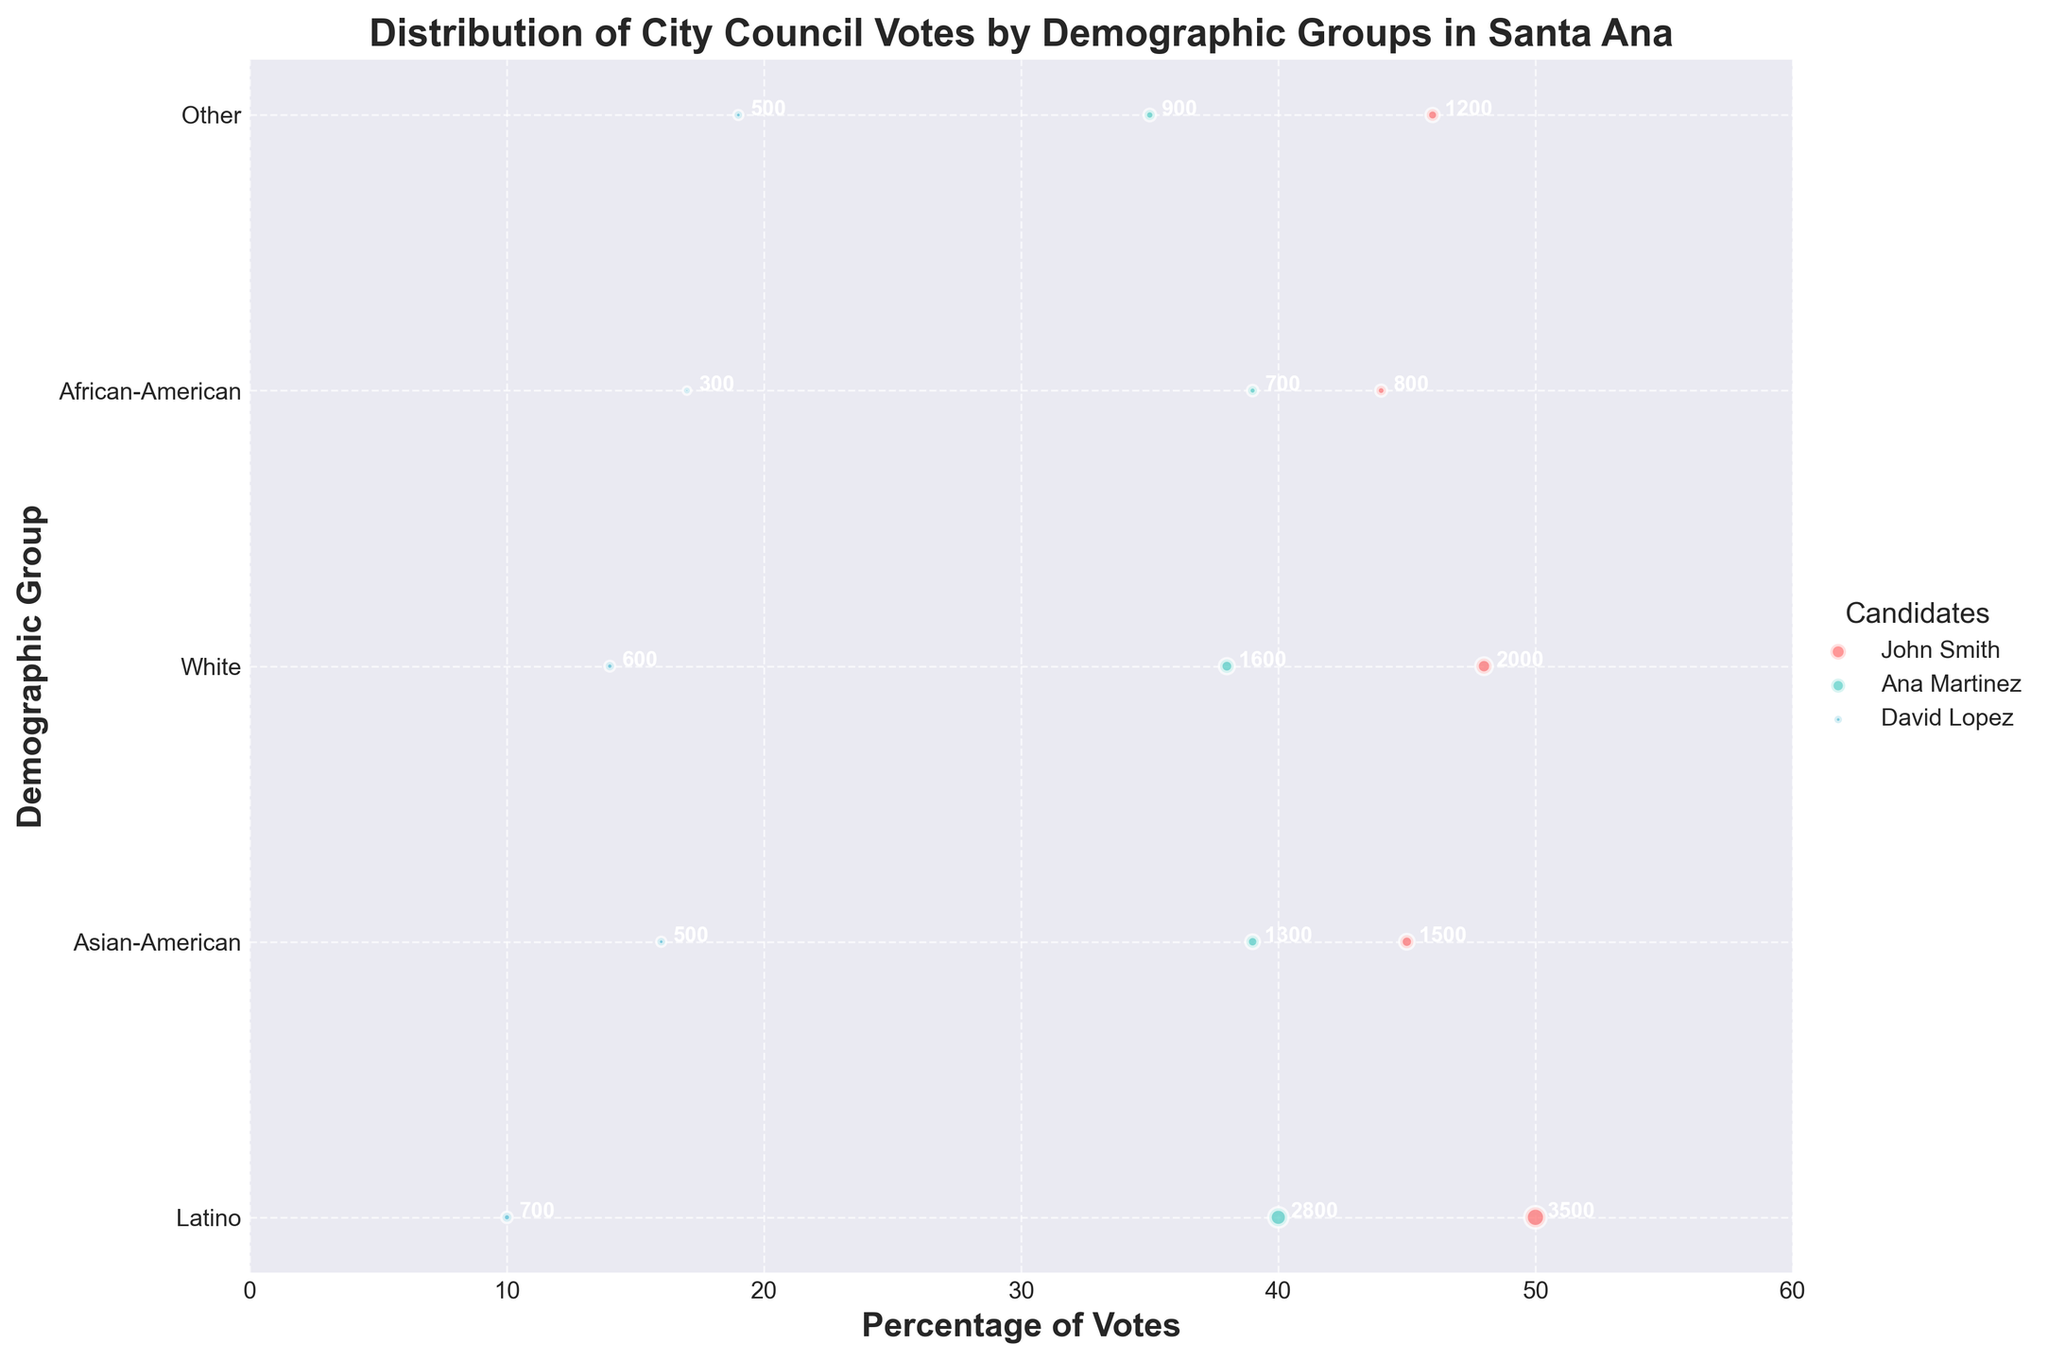What is the title of the figure? The title is usually mentioned at the top of the figure and is labeled "Distribution of City Council Votes by Demographic Groups in Santa Ana."
Answer: Distribution of City Council Votes by Demographic Groups in Santa Ana Which candidate received the most votes overall among all demographic groups? John Smith appears to have larger-sized bubbles across most demographic groups. The sizes are proportional to the number of votes, indicating he received the most votes overall.
Answer: John Smith Which demographic group gave the highest percentage of votes to Ana Martinez? By referring to the x-axis (Percentage of Votes) and comparing the positions of the bubbles for Ana Martinez, the Asian-American group gave her the highest percentage of votes at 39%.
Answer: Asian-American How many votes did David Lopez receive from the Latino demographic group? Each bubble is annotated with the number of votes. The bubble for David Lopez in the Latino group shows 700 votes.
Answer: 700 Which demographic gave the smallest percentage of votes to John Smith? By looking at the x-axis (Percentage of Votes) and comparing the positions of the John Smith bubbles, the African-American group gave him the smallest percentage of votes at 44%.
Answer: African-American For the Latino demographic group, what is the combined percentage of votes for Ana Martinez and David Lopez? The percentage of votes for Ana Martinez is 40%, and for David Lopez, it is 10%. Summing these up, 40% + 10% equals 50%.
Answer: 50% Among the White demographic group, which candidate received the least votes? Comparing the sizes of the bubbles in the White group, David Lopez’s bubble is the smallest, indicating he received the least votes.
Answer: David Lopez How does the percentage of votes for John Smith compare between the Asian-American and Latino demographic groups? The x-axis (Percentage of Votes) position of John Smith's bubbles show 45% for Asian-American and 50% for Latino. Therefore, the Latino group gave him a higher percentage.
Answer: Latino higher Which demographic group has the highest number of votes for a single candidate, and who is that candidate? By looking at the sizes of the bubbles, the Latino group's bubble for John Smith is the largest, indicating he received the highest number of votes (3500).
Answer: Latino, John Smith Is there any demographic group in which David Lopez outperformed Ana Martinez? Comparing bubbles for Ana Martinez and David Lopez across all groups, in no demographic did David Lopez outperform Ana Martinez based on both size and percentage of votes.
Answer: No 